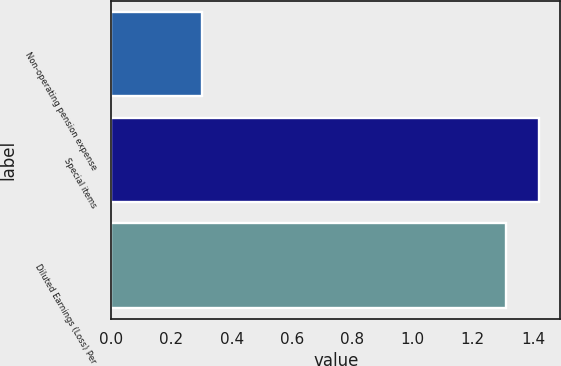Convert chart to OTSL. <chart><loc_0><loc_0><loc_500><loc_500><bar_chart><fcel>Non-operating pension expense<fcel>Special items<fcel>Diluted Earnings (Loss) Per<nl><fcel>0.3<fcel>1.42<fcel>1.31<nl></chart> 